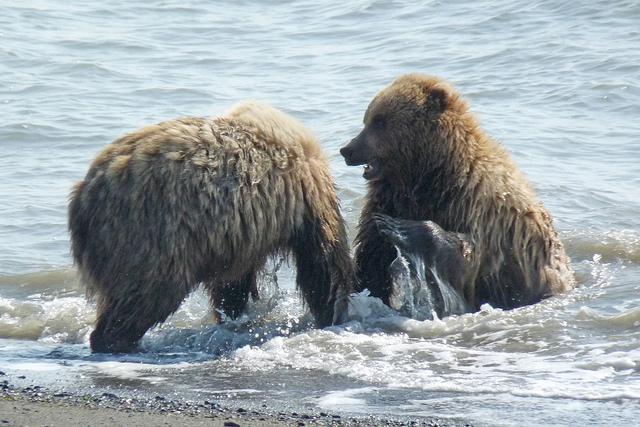What color is the water?
Write a very short answer. Gray. Where are the bears?
Give a very brief answer. In water. How many bears are there?
Quick response, please. 2. 